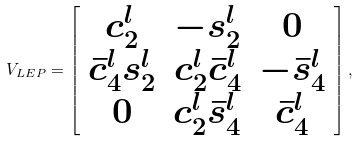<formula> <loc_0><loc_0><loc_500><loc_500>V _ { L E P } = \left [ \begin{array} { c c c } c _ { 2 } ^ { l } & - s _ { 2 } ^ { l } & 0 \\ \bar { c } _ { 4 } ^ { l } s _ { 2 } ^ { l } & c _ { 2 } ^ { l } \bar { c } _ { 4 } ^ { l } & - \bar { s } _ { 4 } ^ { l } \\ 0 & c _ { 2 } ^ { l } \bar { s } _ { 4 } ^ { l } & \bar { c } _ { 4 } ^ { l } \\ \end{array} \right ] ,</formula> 